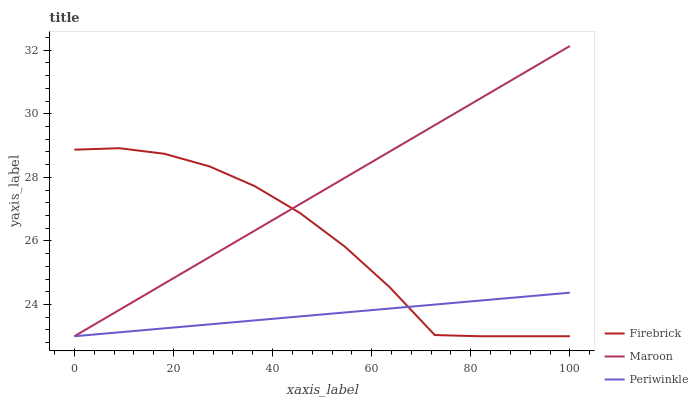Does Periwinkle have the minimum area under the curve?
Answer yes or no. Yes. Does Maroon have the maximum area under the curve?
Answer yes or no. Yes. Does Maroon have the minimum area under the curve?
Answer yes or no. No. Does Periwinkle have the maximum area under the curve?
Answer yes or no. No. Is Maroon the smoothest?
Answer yes or no. Yes. Is Firebrick the roughest?
Answer yes or no. Yes. Is Periwinkle the smoothest?
Answer yes or no. No. Is Periwinkle the roughest?
Answer yes or no. No. Does Firebrick have the lowest value?
Answer yes or no. Yes. Does Maroon have the highest value?
Answer yes or no. Yes. Does Periwinkle have the highest value?
Answer yes or no. No. Does Periwinkle intersect Maroon?
Answer yes or no. Yes. Is Periwinkle less than Maroon?
Answer yes or no. No. Is Periwinkle greater than Maroon?
Answer yes or no. No. 